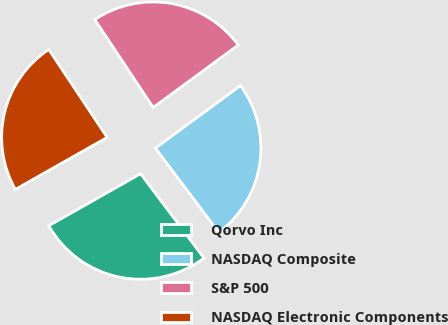Convert chart to OTSL. <chart><loc_0><loc_0><loc_500><loc_500><pie_chart><fcel>Qorvo Inc<fcel>NASDAQ Composite<fcel>S&P 500<fcel>NASDAQ Electronic Components<nl><fcel>27.05%<fcel>24.82%<fcel>24.25%<fcel>23.87%<nl></chart> 